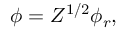<formula> <loc_0><loc_0><loc_500><loc_500>\phi = Z ^ { 1 / 2 } \phi _ { r } ,</formula> 